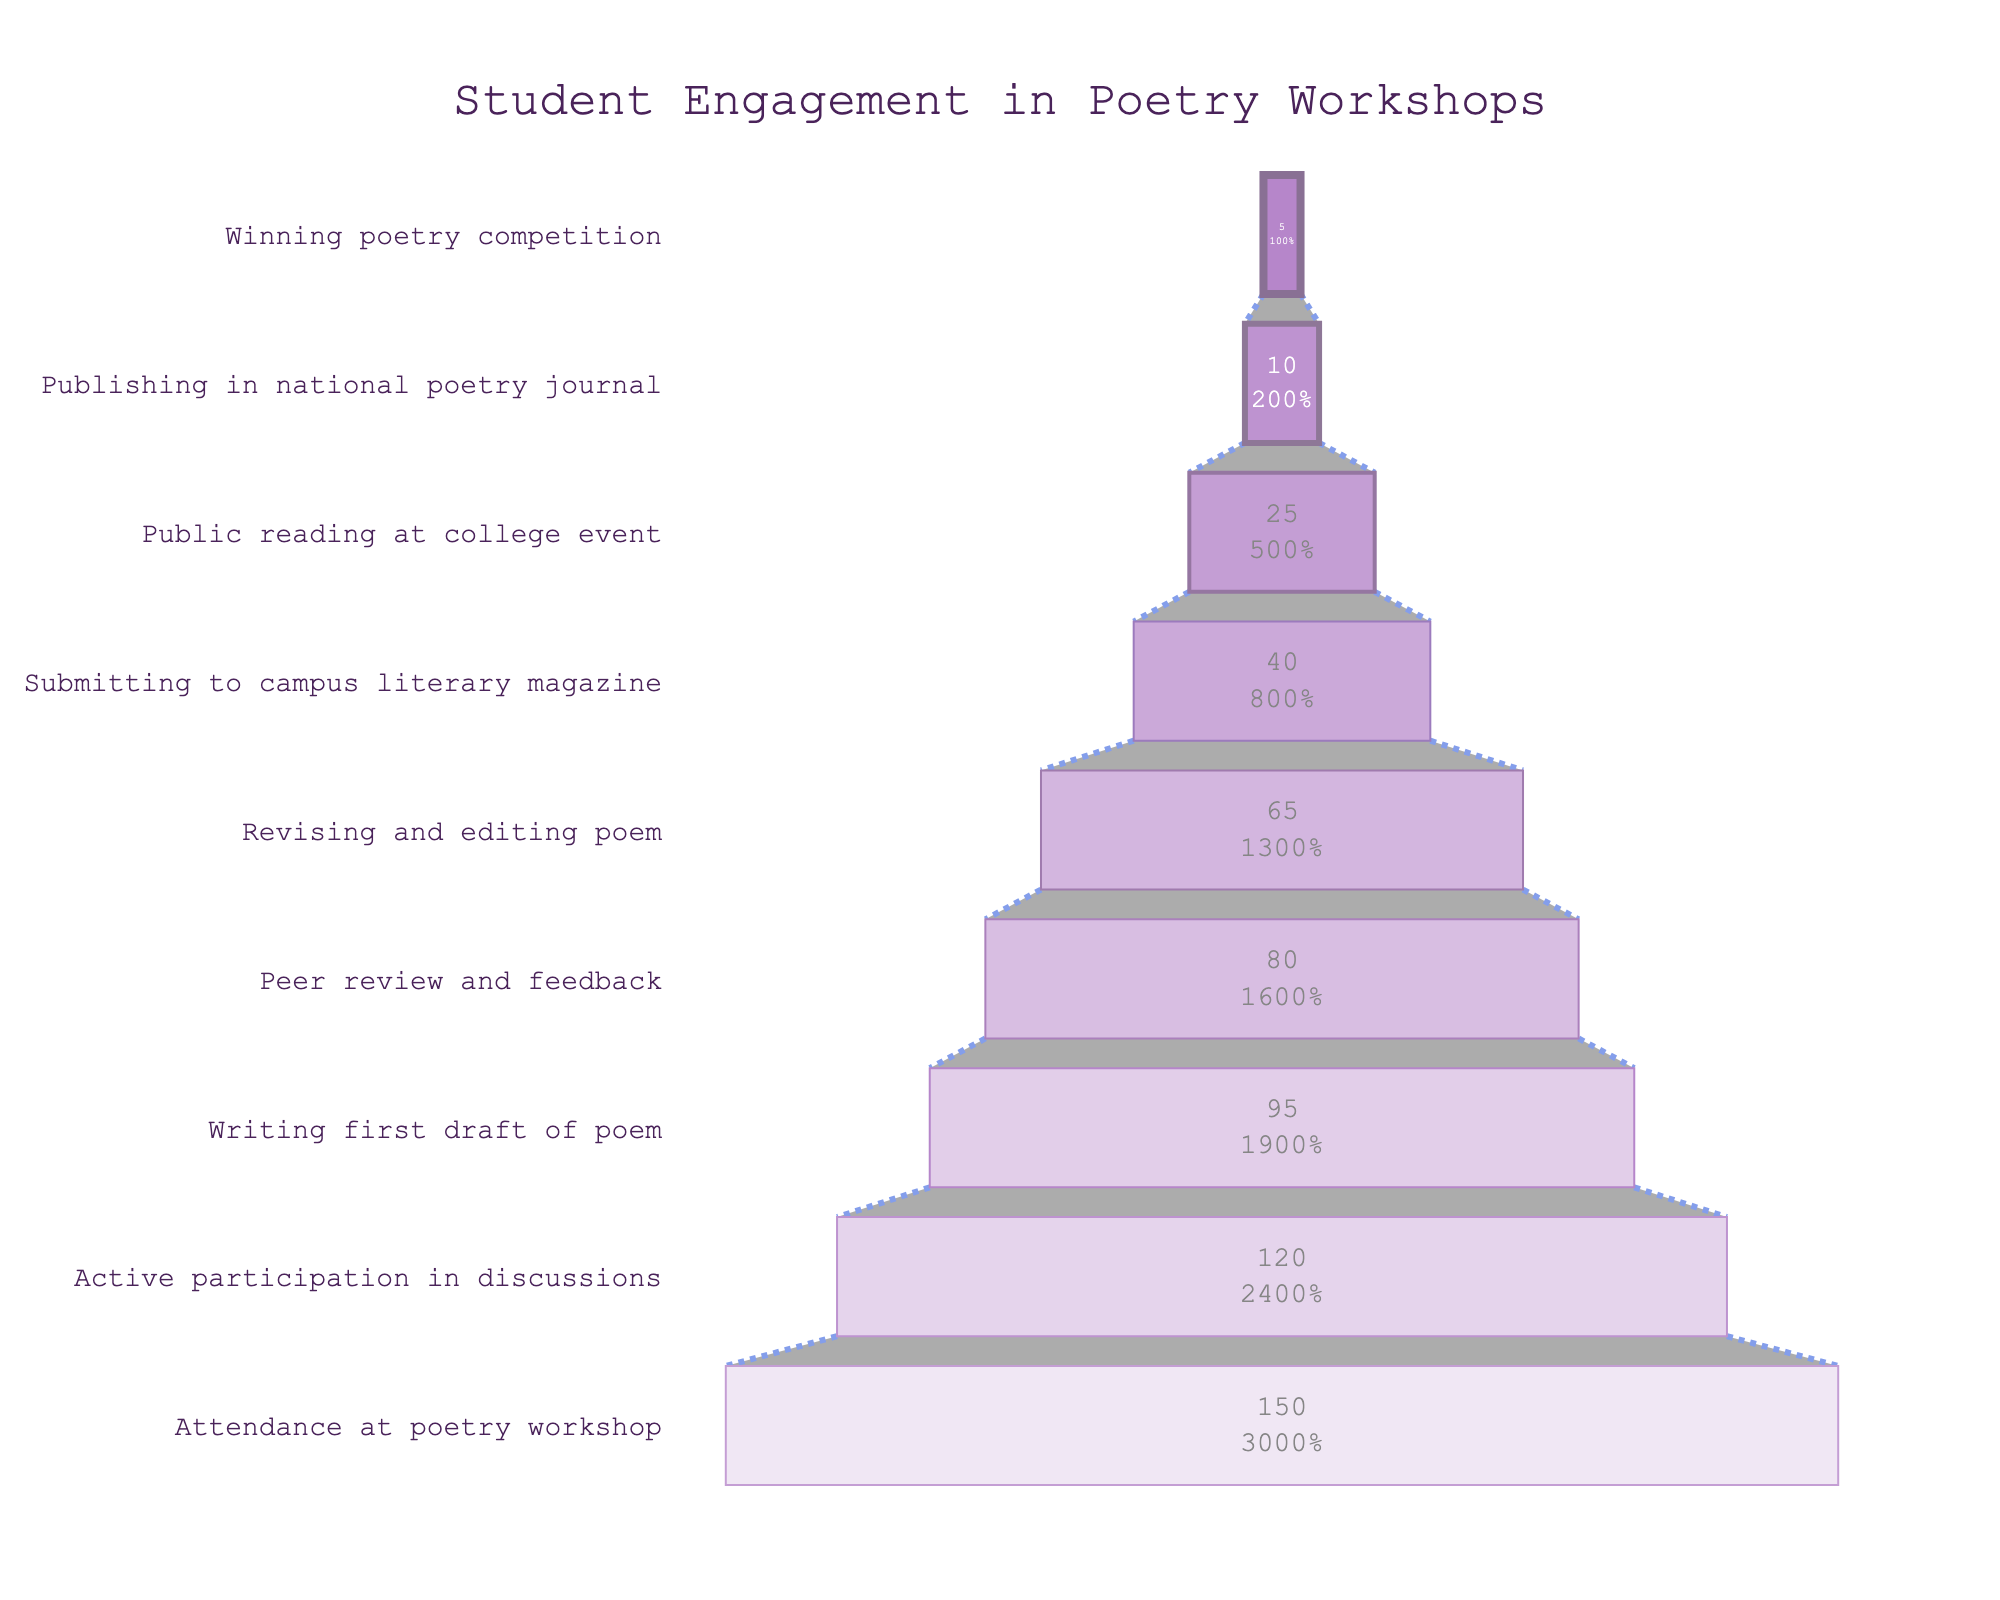What is the title of the funnel chart? The title of the chart can be found at the top center of the figure. It usually provides an overview of what the chart represents.
Answer: Student Engagement in Poetry Workshops How many students participated in the first stage, 'Attendance at poetry workshop'? Look for the first funnel slice from the top, that's generally provided with both the label and number of students.
Answer: 150 Which stage saw participation from 120 students? Identify the stage label corresponding to 120 students from the slices of the funnel chart.
Answer: Active participation in discussions How many stages are there in total? To determine the total number of stages, count all the labeled slices on the funnel chart from top to bottom.
Answer: 9 What is the difference in student numbers between the 'Writing first draft of poem' and 'Revising and editing poem' stages? Find the number of students in both stages and subtract the number for 'Revising and editing poem' from 'Writing first draft of poem'.
Answer: 30 (95 - 65) By what percentage does the number of students decrease from 'Submitting to campus literary magazine' to 'Public reading at college event'? Calculate the number of students at each stage, figure the difference, and then divide by the number of students at the 'Submitting to campus literary magazine' stage, multiply by 100 to get the percentage.
Answer: 37.5% (40 - 25) / 40 * 100 Which stage has the least number of students? Identify the bottom-most slice of the funnel chart, as it represents the stage with the least number of students.
Answer: Winning poetry competition How many more students revised and edited their poems compared to those who published in a national poetry journal? Find the difference between the number of students in 'Revising and editing poem' and 'Publishing in national poetry journal' stages.
Answer: 55 (65 - 10) What is the average number of students from the 'Writing first draft of poem' stage to the 'Winning poetry competition' stage? Add the number of students in all the stages from 'Writing first draft of poem' to 'Winning poetry competition' and divide by the number of stages (which is 7).
Answer: 45 (95 + 80 + 65 + 40 + 25 + 10 + 5 = 320; 320/7 ≈ 45) Which stage saw a drop to less than half the number of students from the initial stage of 'Attendance at poetry workshop'? Identify a stage where the number of students is less than 75 (which is half of 150).
Answer: Writing first draft of poem (75 < 95) 